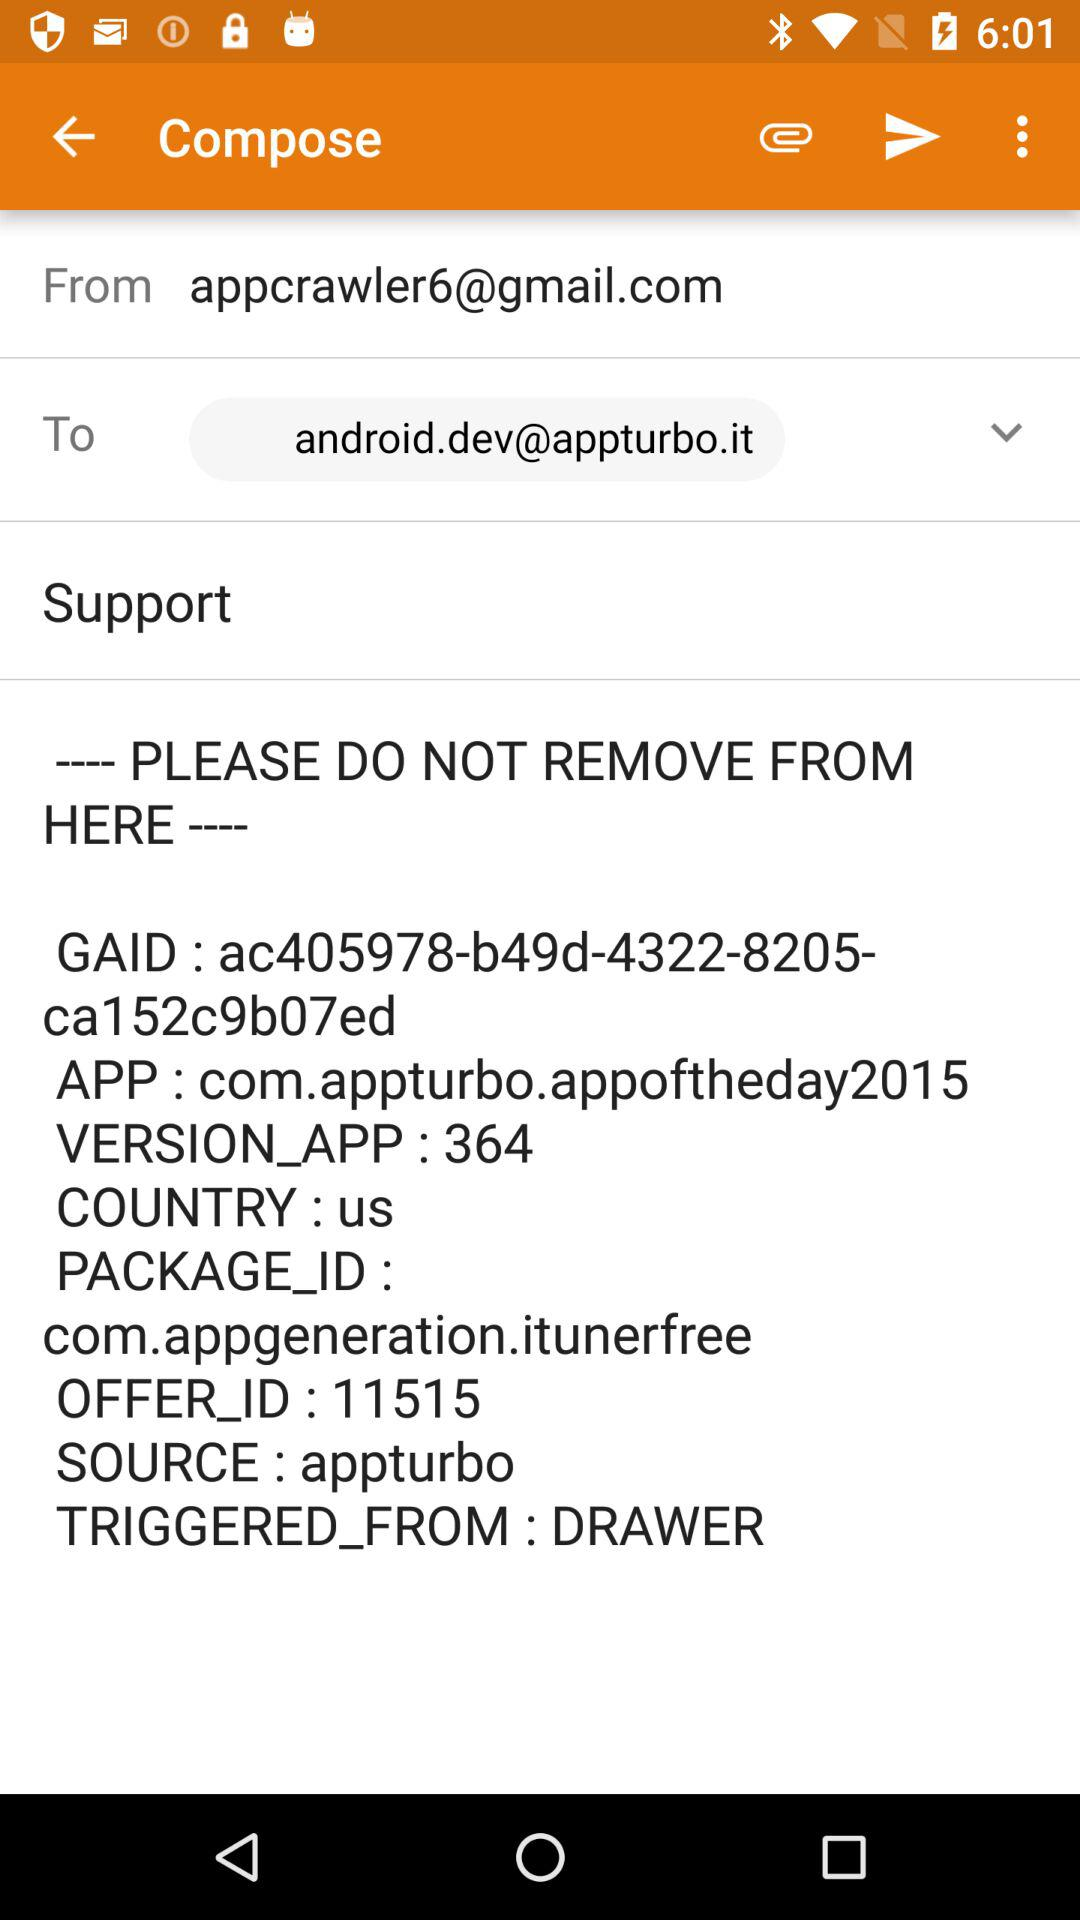What is the "OFFER_ID"? The "OFFER_ID" is 11515. 